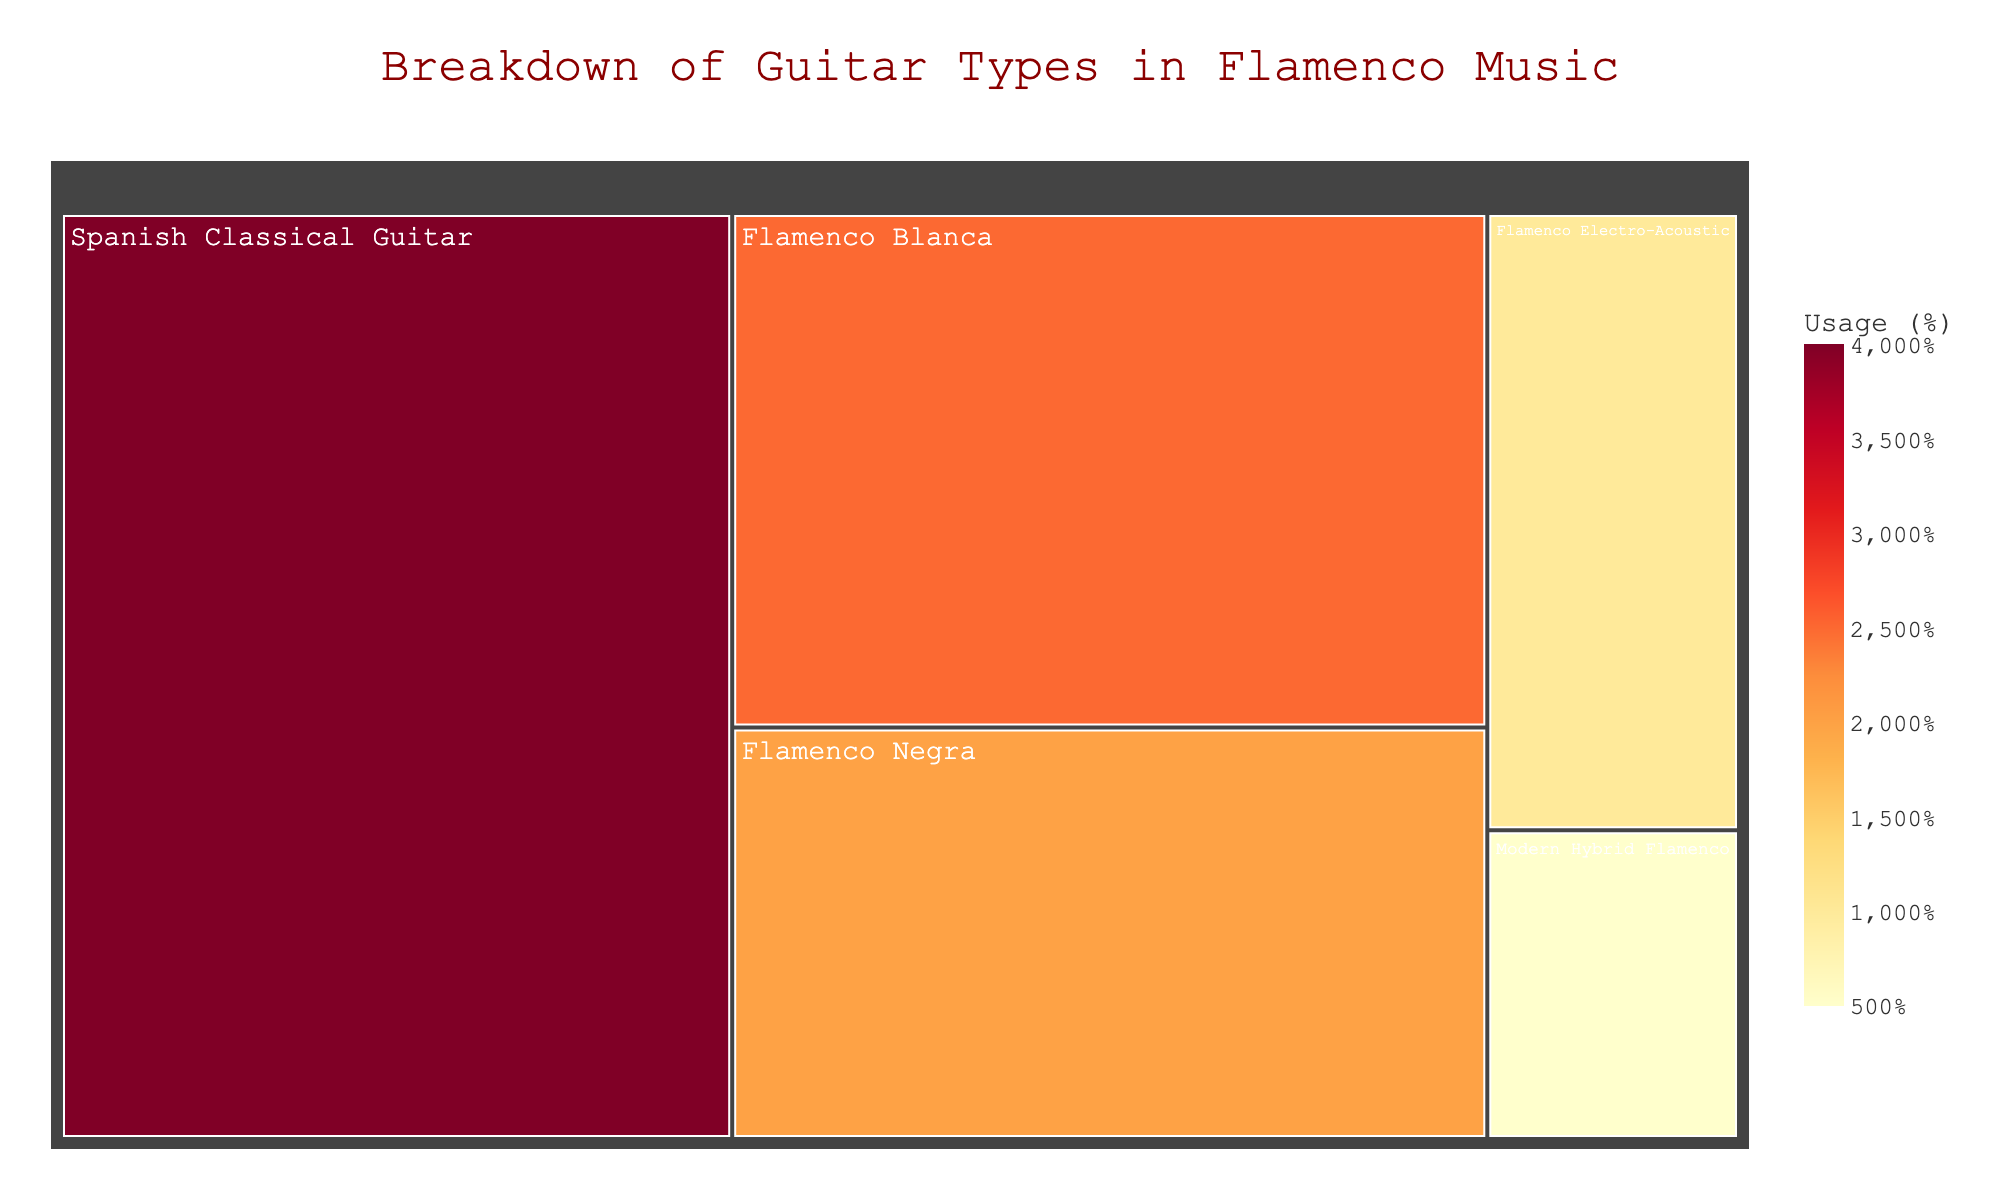Which guitar type has the highest percentage in flamenco music? The figure shows the breakdown of guitar types by percentage. The largest section in the treemap represents the Spanish Classical Guitar, which has the highest percentage.
Answer: Spanish Classical Guitar What percentage of the guitars used in flamenco music are Flamenco Blanca? The treemap shows a section labeled Flamenco Blanca with a percentage value. By looking at this section, we can see that Flamenco Blanca guitars make up 25% of the total.
Answer: 25% What is the combined percentage of Flamenco Blanca and Flamenco Negra guitars? To get the combined percentage of Flamenco Blanca and Flamenco Negra, sum the values associated with each type. From the treemap, Flamenco Blanca is 25% and Flamenco Negra is 20%. Therefore, 25% + 20% = 45%.
Answer: 45% How does the usage of Modern Hybrid Flamenco guitars compare to that of Flamenco Electro-Acoustic guitars? The treemap shows that Modern Hybrid Flamenco guitars account for 5% while Flamenco Electro-Acoustic guitars account for 10%. By comparing these figures, we can see that Modern Hybrid Flamenco guitars are used half as much as Flamenco Electro-Acoustic guitars.
Answer: Modern Hybrid Flamenco guitars are used half as much as Flamenco Electro-Acoustic guitars Which two guitar types together make up 50% of the usage in flamenco music? To determine which two guitar types together make up 50%, we sum the percentages for each combination. By examining the treemap, we see that Flamenco Blanca (25%) and Flamenco Negra (20%) together make up 45%, and Flamenco Electro-Acoustic (10%) added to Flamenco Blanca (25%) makes 35%. However, combining Flamenco Negra (20%) and Flamenco Electro-Acoustic (10%) results in just 30%. Therefore, no two specific guitar types add up exactly to 50%.
Answer: None What is the combined percentage of the three least used guitar types? The three least used guitar types are Flamenco Negra (20%), Flamenco Electro-Acoustic (10%), and Modern Hybrid Flamenco (5%). Adding their percentages together gives 20% + 10% + 5% = 35%.
Answer: 35% Which guitar types have usage percentages less than 30%? By reviewing the treemap, the guitar types with less than 30% usage are Flamenco Blanca (25%), Flamenco Negra (20%), Flamenco Electro-Acoustic (10%), and Modern Hybrid Flamenco (5%).
Answer: Flamenco Blanca, Flamenco Negra, Flamenco Electro-Acoustic, Modern Hybrid Flamenco What percentage do the Flamenco Blanca and Flamenco Negra guitars together hold out of the specific flamenco guitars listed (excluding the Spanish Classical Guitar)? By combining Flamenco Blanca (25%) and Flamenco Negra (20%) only among the flamenco-specific guitar types (Flamenco Blanca, Flamenco Negra, Flamenco Electro-Acoustic, Modern Hybrid Flamenco), we sum them to get 25% + 20% = 45%.
Answer: 45% 